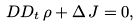Convert formula to latex. <formula><loc_0><loc_0><loc_500><loc_500>\ D D _ { t } \, \rho + \Delta \, J = 0 ,</formula> 